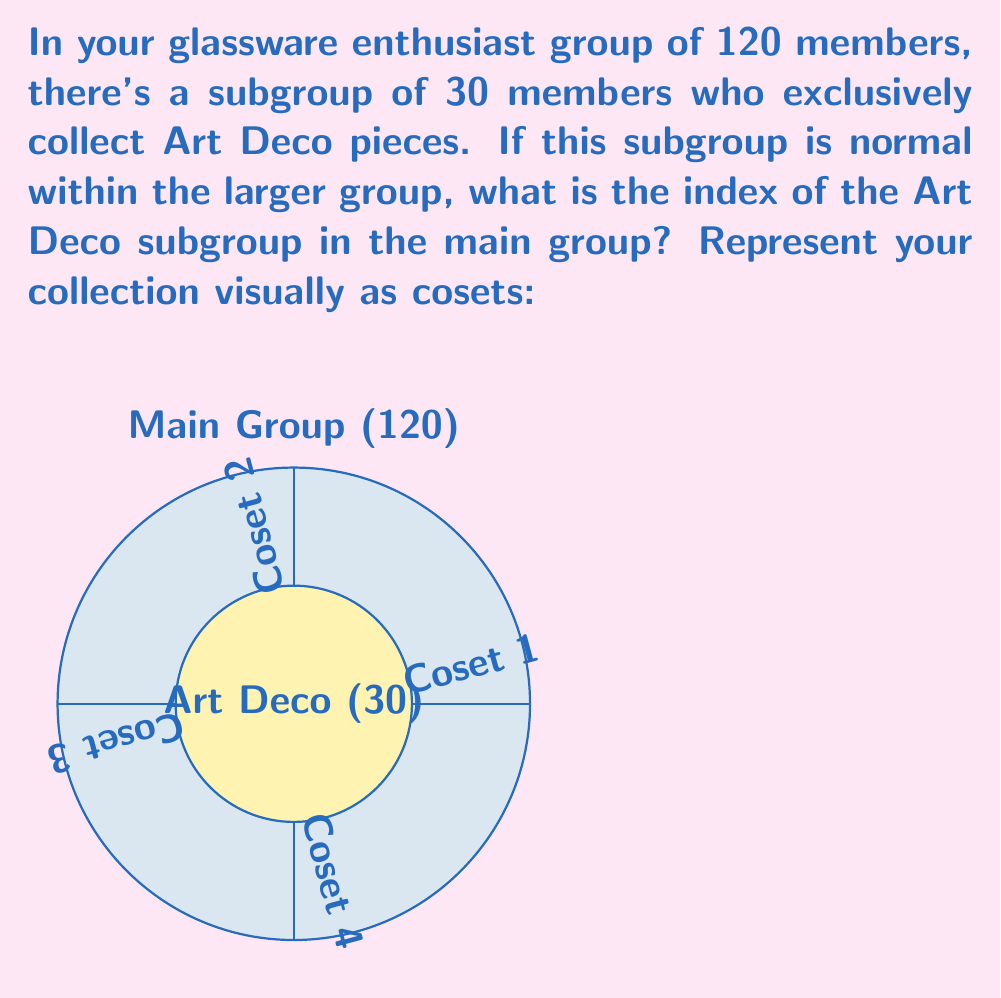Could you help me with this problem? Let's approach this step-by-step:

1) The index of a subgroup $H$ in a group $G$ is defined as:

   $[G:H] = \frac{|G|}{|H|}$

   where $|G|$ is the order of the main group and $|H|$ is the order of the subgroup.

2) In this case:
   - $|G| = 120$ (the total number of members in the main group)
   - $|H| = 30$ (the number of members in the Art Deco subgroup)

3) Substituting these values into the formula:

   $[G:H] = \frac{120}{30}$

4) Simplifying:

   $[G:H] = 4$

5) This result means that there are 4 distinct cosets of the Art Deco subgroup within the main group, which is visually represented in the diagram.

6) Each coset contains 30 members, and there are 4 cosets, which together make up the entire group of 120 members (30 * 4 = 120).

The index of 4 indicates that the main group can be partitioned into 4 equal-sized sets, each a copy of the Art Deco subgroup, but shifted by the group operation.
Answer: $4$ 